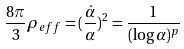Convert formula to latex. <formula><loc_0><loc_0><loc_500><loc_500>\frac { 8 \pi } { 3 } \rho _ { e f f } = ( \frac { \dot { \alpha } } { \alpha } ) ^ { 2 } = \frac { 1 } { ( \log \alpha ) ^ { p } }</formula> 